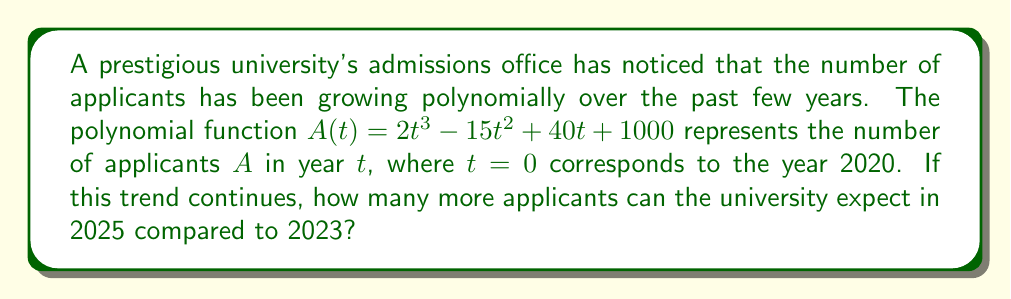Help me with this question. To solve this problem, we need to follow these steps:

1. Calculate the number of applicants in 2023:
   For 2023, $t = 3$ (since 2020 is $t = 0$)
   $A(3) = 2(3)^3 - 15(3)^2 + 40(3) + 1000$
   $= 2(27) - 15(9) + 120 + 1000$
   $= 54 - 135 + 120 + 1000$
   $= 1039$ applicants

2. Calculate the number of applicants in 2025:
   For 2025, $t = 5$
   $A(5) = 2(5)^3 - 15(5)^2 + 40(5) + 1000$
   $= 2(125) - 15(25) + 200 + 1000$
   $= 250 - 375 + 200 + 1000$
   $= 1075$ applicants

3. Calculate the difference between 2025 and 2023:
   Difference = $A(5) - A(3) = 1075 - 1039 = 36$

Therefore, the university can expect 36 more applicants in 2025 compared to 2023.
Answer: 36 applicants 